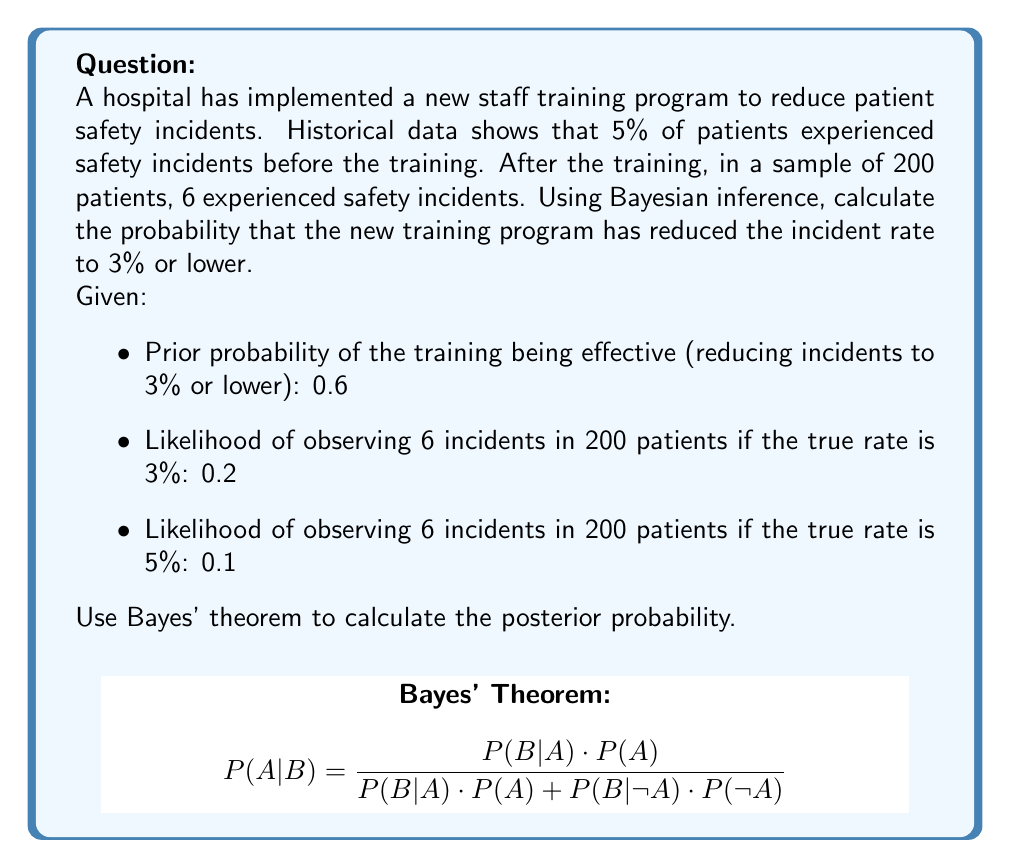Give your solution to this math problem. To solve this problem using Bayesian inference, we'll follow these steps:

1) Recall Bayes' theorem:

   $$P(A|B) = \frac{P(B|A) \cdot P(A)}{P(B)}$$

   Where:
   A = Event that the training reduced incidents to 3% or lower
   B = Observed data (6 incidents in 200 patients)

2) We're given:
   $P(A) = 0.6$ (prior probability)
   $P(B|A) = 0.2$ (likelihood if rate is 3%)
   $P(B|\text{not }A) = 0.1$ (likelihood if rate is 5%)

3) Calculate $P(B)$ using the law of total probability:

   $$P(B) = P(B|A) \cdot P(A) + P(B|\text{not }A) \cdot P(\text{not }A)$$
   $$P(B) = 0.2 \cdot 0.6 + 0.1 \cdot 0.4 = 0.12 + 0.04 = 0.16$$

4) Now we can apply Bayes' theorem:

   $$P(A|B) = \frac{P(B|A) \cdot P(A)}{P(B)} = \frac{0.2 \cdot 0.6}{0.16} = \frac{0.12}{0.16} = 0.75$$

Therefore, the posterior probability that the training program has reduced the incident rate to 3% or lower, given the observed data, is 0.75 or 75%.
Answer: 0.75 